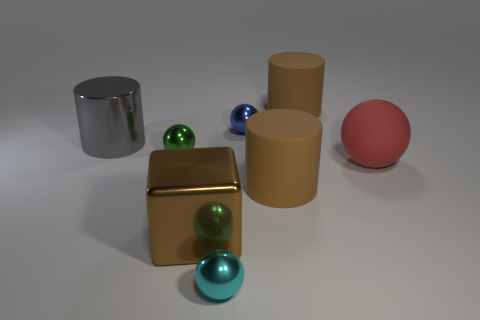What color is the metallic sphere that is in front of the brown thing left of the matte cylinder in front of the small green object?
Your answer should be compact. Cyan. Is the shape of the blue metal thing the same as the gray thing?
Your response must be concise. No. Are there an equal number of red balls to the right of the big red matte object and tiny brown cubes?
Keep it short and to the point. Yes. What number of other objects are there of the same material as the large block?
Provide a succinct answer. 4. Is the size of the rubber cylinder behind the big red object the same as the metallic thing that is in front of the brown block?
Offer a terse response. No. How many things are big rubber cylinders in front of the large sphere or large cylinders that are behind the metallic cylinder?
Provide a short and direct response. 2. Are there any other things that are the same shape as the large brown metal thing?
Offer a very short reply. No. There is a matte cylinder that is behind the red matte sphere; is it the same color as the large rubber cylinder in front of the blue shiny sphere?
Give a very brief answer. Yes. What number of metallic things are big spheres or brown balls?
Offer a terse response. 0. The small metal object in front of the ball that is to the left of the small cyan metal ball is what shape?
Offer a very short reply. Sphere. 